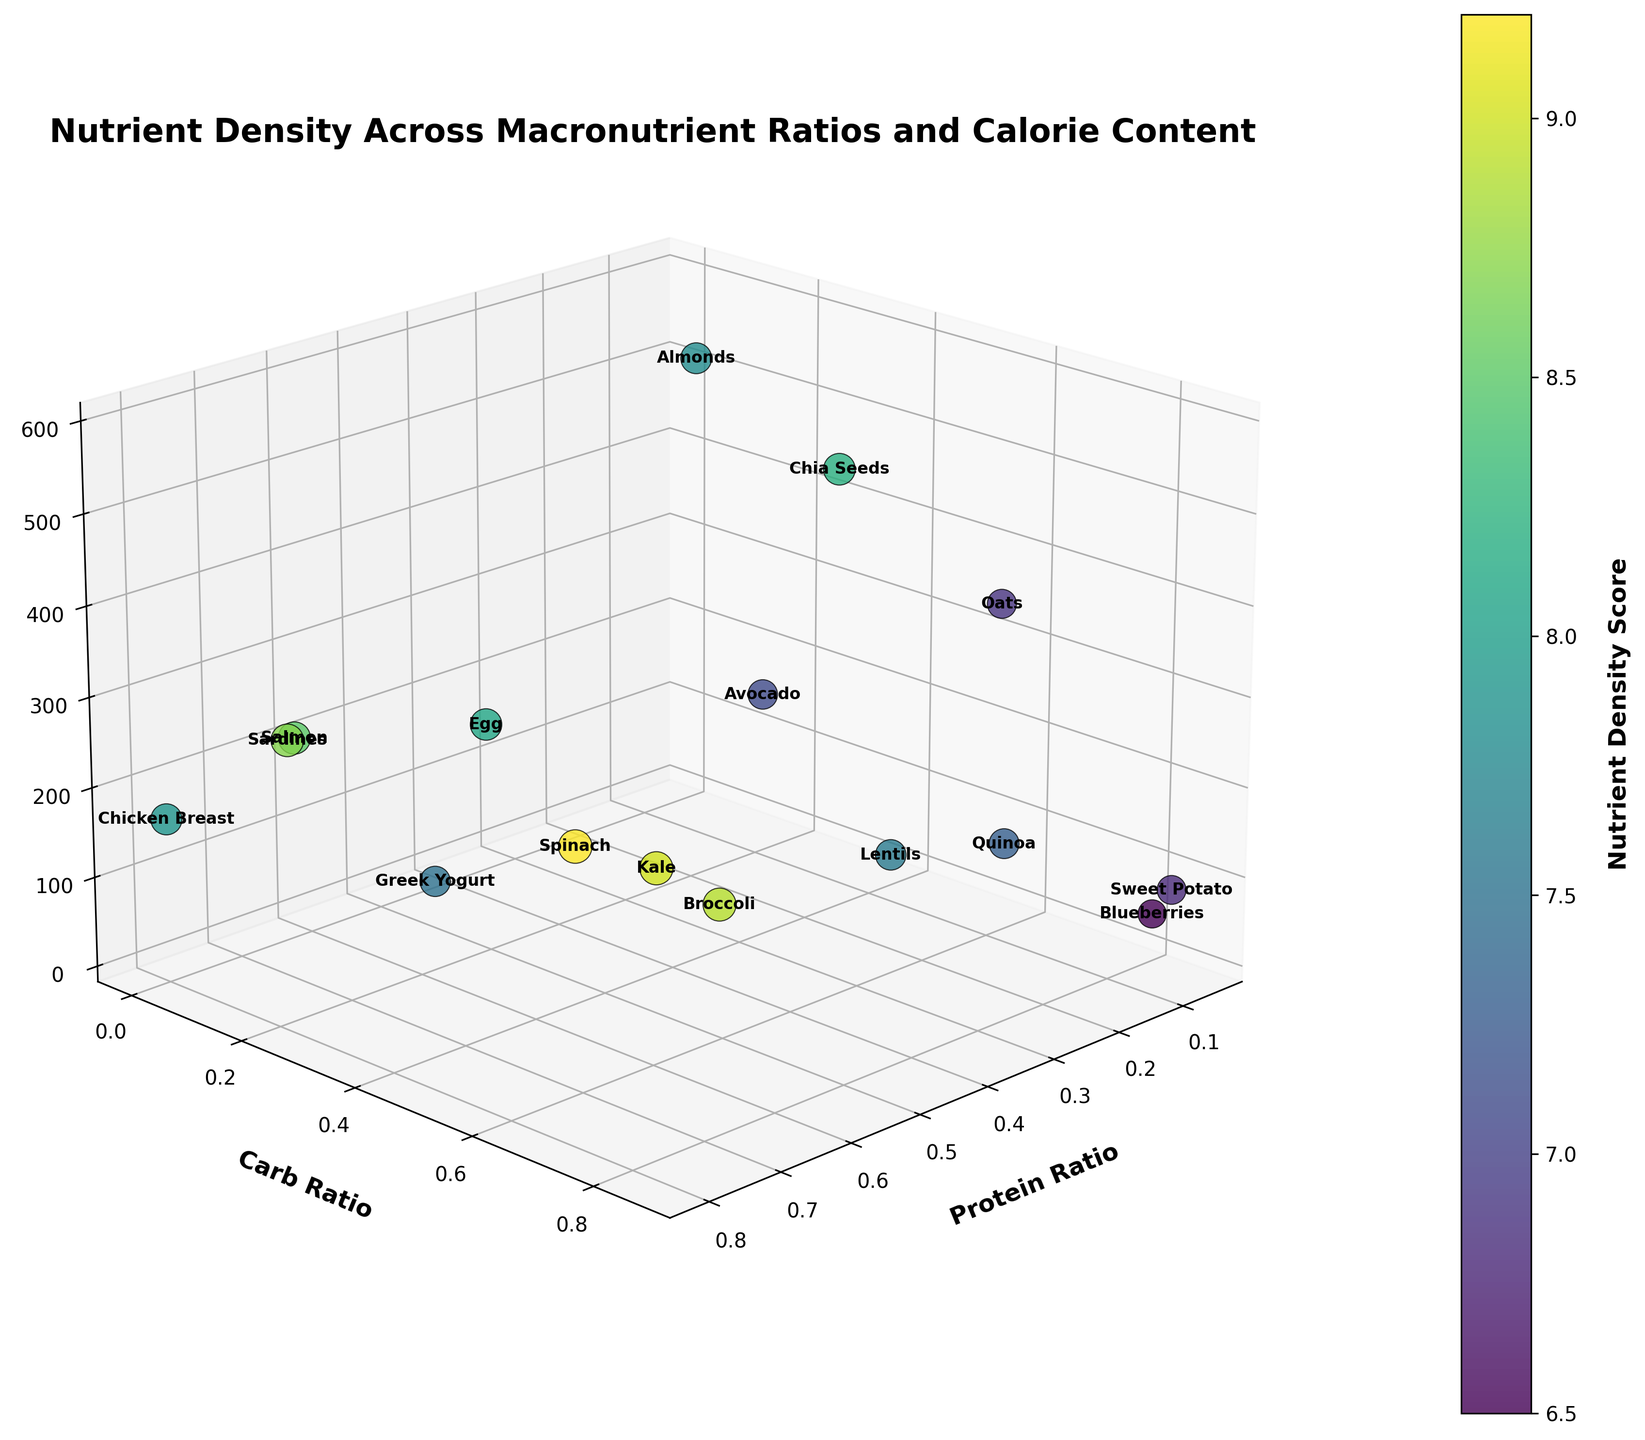What is the title of the figure? The title is located at the top of the figure. It summarizes the main topic of the plot.
Answer: Nutrient Density Across Macronutrient Ratios and Calorie Content What are the axes labels? The axes labels provide information about what each axis represents. The plot has three axes labeled as follows: X-axis is 'Protein Ratio', Y-axis is 'Carb Ratio', and Z-axis is 'Calories per 100g'.
Answer: Protein Ratio, Carb Ratio, Calories per 100g Which food item has the highest nutrient density score? To find the highest nutrient density score, look at the colorbar and find the darkest color point on the plot. The label next to this point will identify the food.
Answer: Spinach How many food items have a carbohydrate ratio greater than 0.5? Count the number of points in the figure where the Y-axis value (Carb Ratio) is greater than 0.5. These points will be placed higher on the Y-axis.
Answer: 4 Which food item is lowest in calories per 100g? Check the Z-axis (Calories per 100g) and find the point that is closest to the origin (lowest on the Z-axis). Verify the label to identify the food item.
Answer: Spinach What is the approximate caloric value of Greek Yogurt? Locate Greek Yogurt on the plot by finding its label and then read off its position on the Z-axis to find the caloric value.
Answer: 59 Which has a higher protein ratio, Salmon or Chicken Breast? Identify Salmon and Chicken Breast on the plot and compare their positions on the X-axis (Protein Ratio). The one further along the axis has the higher protein ratio.
Answer: Chicken Breast Between Broccoli and Lentils, which has a higher nutrient density score? Locate Broccoli and Lentils on the plot and compare their corresponding colors based on the colorbar, which indicates the nutrient density score. The darker the color, the higher the nutrient density score.
Answer: Broccoli What is the average nutrient density score of Almonds, Quinoa, and Chia Seeds? Locate Almonds, Quinoa, and Chia Seeds on the plot, read their nutrient density scores and then calculate the average. (7.8 + 7.3 + 8.2) / 3 = 7.7667
Answer: 7.77 Which food item has the highest combined ratio of protein and carbs? Add the protein ratio and carb ratio for each food item and compare. The food item with the highest sum will have the highest combined ratio. Broccoli has a combined ratio of 0.73 and Kale has one of 0.62.
Answer: Broccoli 